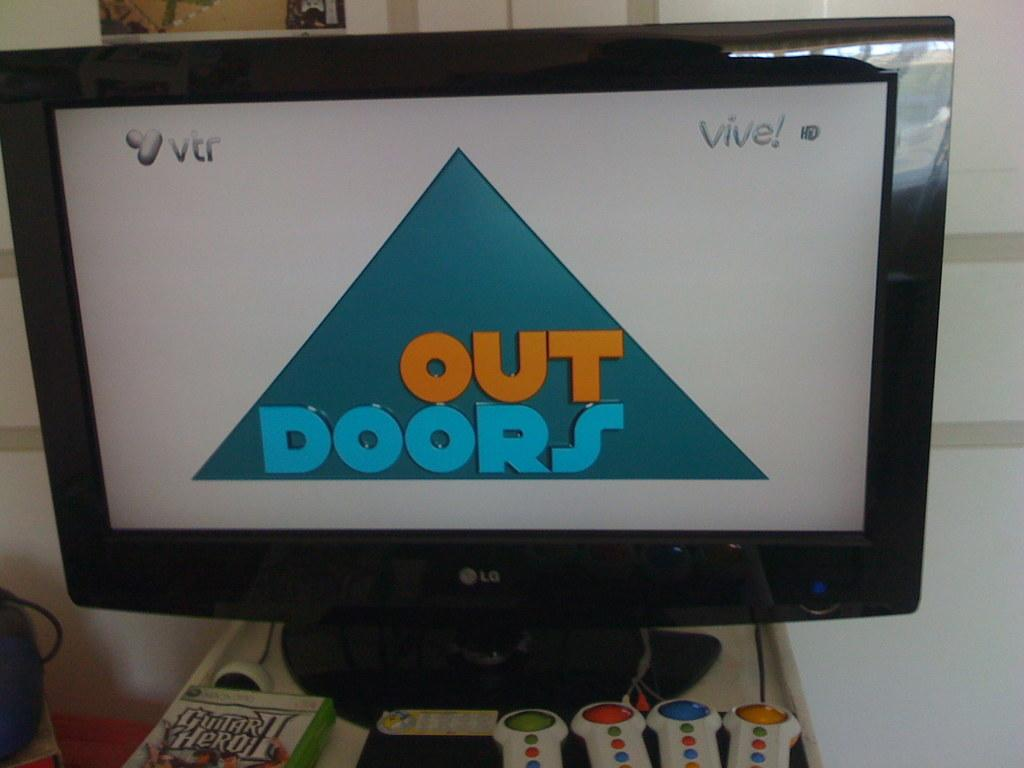Provide a one-sentence caption for the provided image. an lg screen that says 'out doors' on it. 